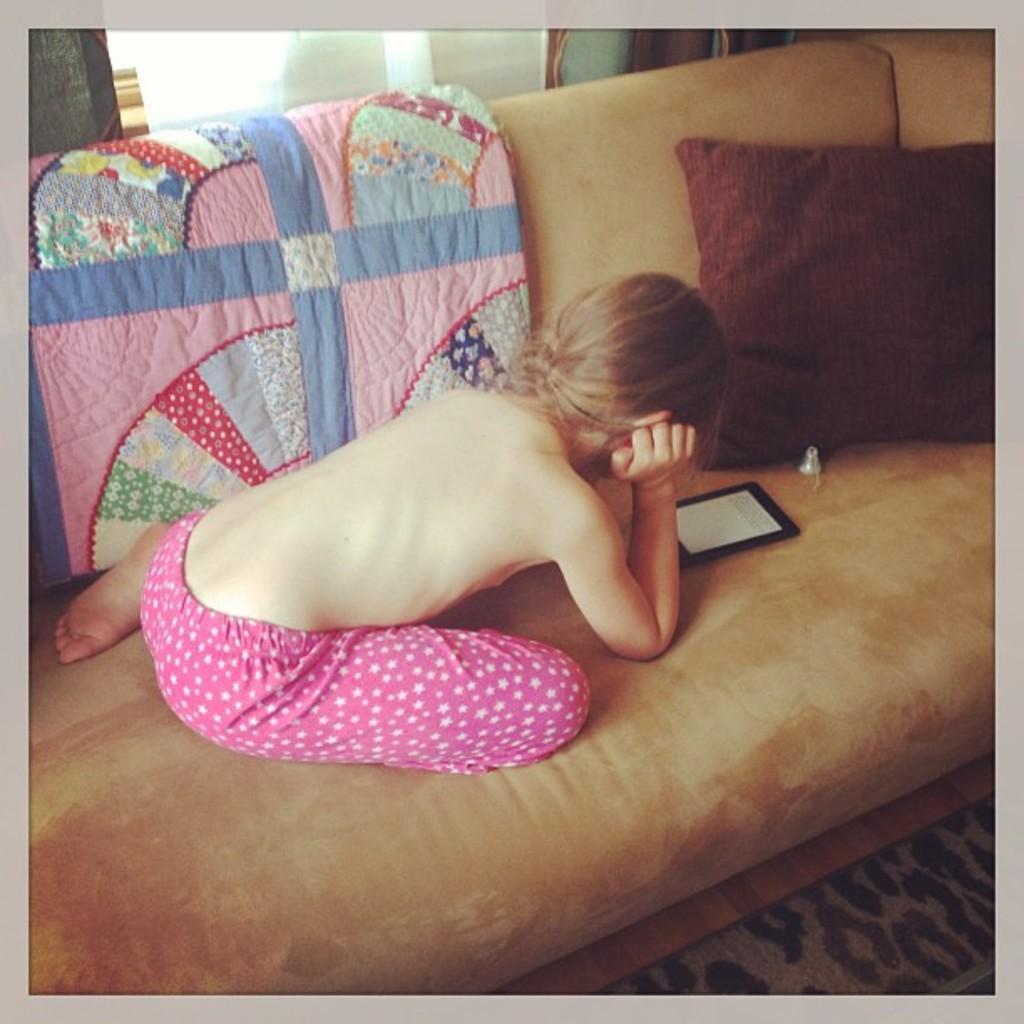Describe this image in one or two sentences. This picture is clicked inside and seems to be an edited image with the borders. In the center there is a person sitting on a couch and we see a cushion and a tablet placed on the top of the couch. In the background we can see the wall and some other objects. 